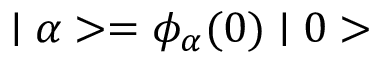<formula> <loc_0><loc_0><loc_500><loc_500>| \alpha > = \phi _ { \alpha } ( 0 ) | 0 ></formula> 